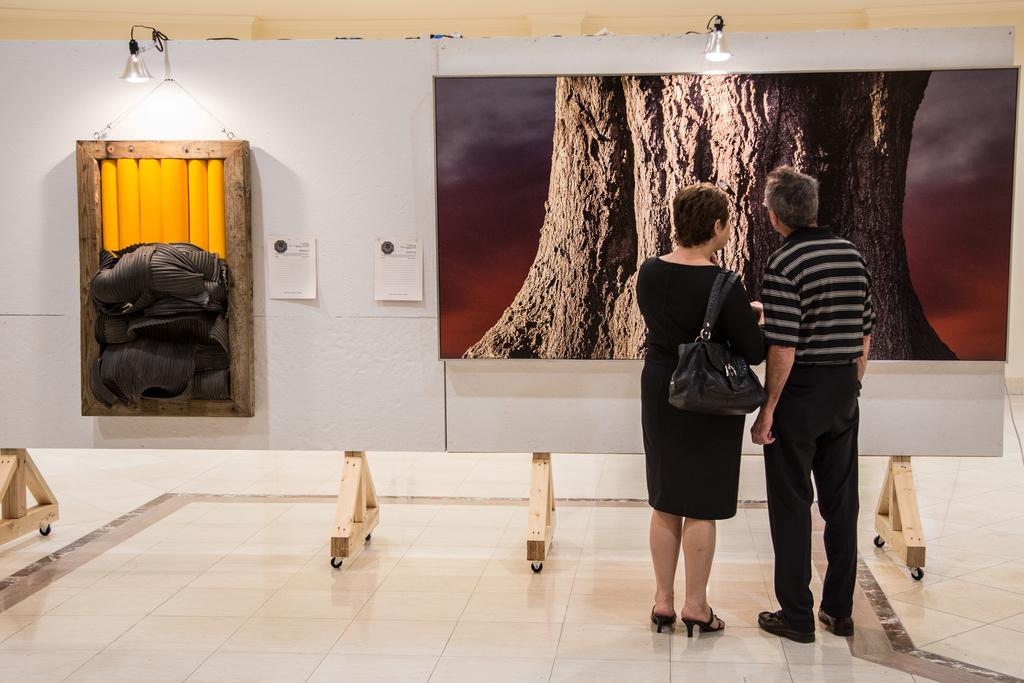How many people are in the image? There are two people in the image, a man and a woman. Where are the man and woman located in the image? Both the man and woman are standing on the right side of the image. What can be seen in the background of the image? There is a wall in the background of the image. What is present on the wall in the image? There is a poster in the image. What is attached to the poster in the image? There are objects attached to the poster. How many oranges are being experienced by the man and woman in the image? There are no oranges present in the image, so it is not possible to determine if they are being experienced or not. 